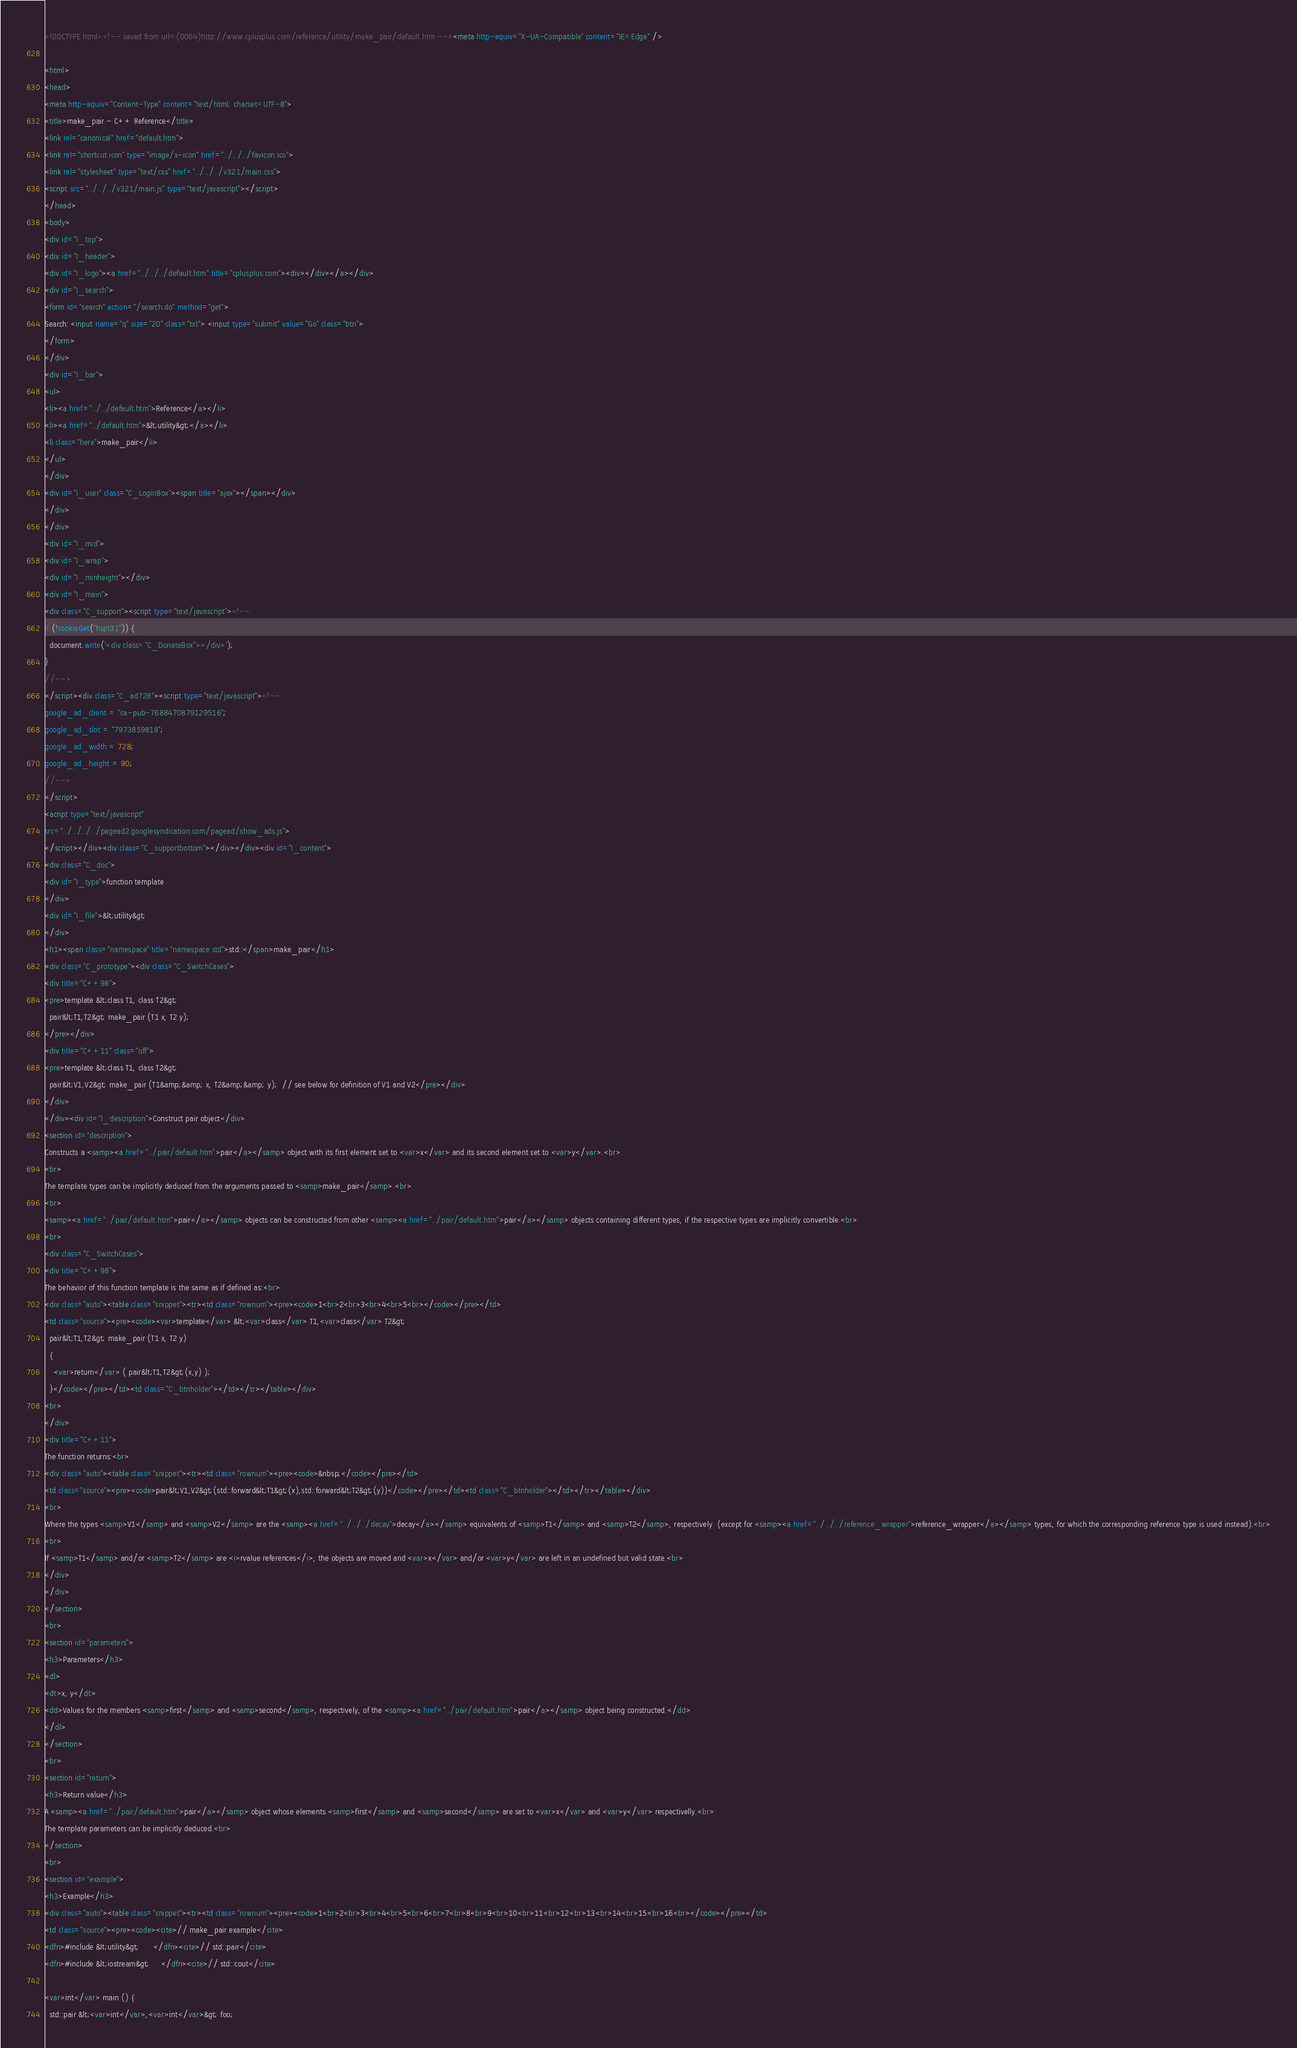<code> <loc_0><loc_0><loc_500><loc_500><_HTML_><!DOCTYPE html><!-- saved from url=(0064)http://www.cplusplus.com/reference/utility/make_pair/default.htm --><meta http-equiv="X-UA-Compatible" content="IE=Edge" />

<html>
<head>
<meta http-equiv="Content-Type" content="text/html; charset=UTF-8">
<title>make_pair - C++ Reference</title>
<link rel="canonical" href="default.htm">
<link rel="shortcut icon" type="image/x-icon" href="../../../favicon.ico">
<link rel="stylesheet" type="text/css" href="../../../v321/main.css">
<script src="../../../v321/main.js" type="text/javascript"></script>
</head>
<body>
<div id="I_top">
<div id="I_header">
<div id="I_logo"><a href="../../../default.htm" title="cplusplus.com"><div></div></a></div>
<div id="I_search">
<form id="search" action="/search.do" method="get">
Search: <input name="q" size="20" class="txt"> <input type="submit" value="Go" class="btn">
</form>
</div>
<div id="I_bar">
<ul>
<li><a href="../../default.htm">Reference</a></li>
<li><a href="../default.htm">&lt;utility&gt;</a></li>
<li class="here">make_pair</li>
</ul>
</div>
<div id="I_user" class="C_LoginBox"><span title="ajax"></span></div>
</div>
</div>
<div id="I_mid">
<div id="I_wrap">
<div id="I_minheight"></div>
<div id="I_main">
<div class="C_support"><script type="text/javascript"><!--
if (!cookieGet("hspt31")) {
  document.write('<div class="C_DonateBox"></div>');
}
//-->
</script><div class="C_ad728"><script type="text/javascript"><!--
google_ad_client = "ca-pub-7688470879129516";
google_ad_slot = "7973859818";
google_ad_width = 728;
google_ad_height = 90;
//-->
</script>
<acript type="text/javascript"
src="../../../../pagead2.googlesyndication.com/pagead/show_ads.js">
</script></div><div class="C_supportbottom"></div></div><div id="I_content">
<div class="C_doc">
<div id="I_type">function template</div>
<div id="I_file">&lt;utility&gt;</div>
<h1><span class="namespace" title="namespace std">std::</span>make_pair</h1>
<div class="C_prototype"><div class="C_SwitchCases">
<div title="C++98">
<pre>template &lt;class T1, class T2&gt;  pair&lt;T1,T2&gt; make_pair (T1 x, T2 y);</pre></div>
<div title="C++11" class="off">
<pre>template &lt;class T1, class T2&gt;  pair&lt;V1,V2&gt; make_pair (T1&amp;&amp; x, T2&amp;&amp; y);  // see below for definition of V1 and V2</pre></div>
</div>
</div><div id="I_description">Construct pair object</div>
<section id="description">
Constructs a <samp><a href="../pair/default.htm">pair</a></samp> object with its first element set to <var>x</var> and its second element set to <var>y</var>.<br>
<br>
The template types can be implicitly deduced from the arguments passed to <samp>make_pair</samp>.<br>
<br>
<samp><a href="../pair/default.htm">pair</a></samp> objects can be constructed from other <samp><a href="../pair/default.htm">pair</a></samp> objects containing different types, if the respective types are implicitly convertible.<br>
<br>
<div class="C_SwitchCases">
<div title="C++98">
The behavior of this function template is the same as if defined as:<br>
<div class="auto"><table class="snippet"><tr><td class="rownum"><pre><code>1<br>2<br>3<br>4<br>5<br></code></pre></td>
<td class="source"><pre><code><var>template</var> &lt;<var>class</var> T1,<var>class</var> T2&gt;
  pair&lt;T1,T2&gt; make_pair (T1 x, T2 y)
  {
    <var>return</var> ( pair&lt;T1,T2&gt;(x,y) );
  }</code></pre></td><td class="C_btnholder"></td></tr></table></div>
<br>
</div>
<div title="C++11">
The function returns:<br>
<div class="auto"><table class="snippet"><tr><td class="rownum"><pre><code>&nbsp;</code></pre></td>
<td class="source"><pre><code>pair&lt;V1,V2&gt;(std::forward&lt;T1&gt;(x),std::forward&lt;T2&gt;(y))</code></pre></td><td class="C_btnholder"></td></tr></table></div>
<br>
Where the types <samp>V1</samp> and <samp>V2</samp> are the <samp><a href="../../../decay">decay</a></samp> equivalents of <samp>T1</samp> and <samp>T2</samp>, respectively  (except for <samp><a href="../../../reference_wrapper">reference_wrapper</a></samp> types, for which the corresponding reference type is used instead).<br>
<br>
If <samp>T1</samp> and/or <samp>T2</samp> are <i>rvalue references</i>, the objects are moved and <var>x</var> and/or <var>y</var> are left in an undefined but valid state.<br>
</div>
</div>
</section>
<br>
<section id="parameters">
<h3>Parameters</h3>
<dl>
<dt>x, y</dt>
<dd>Values for the members <samp>first</samp> and <samp>second</samp>, respectively, of the <samp><a href="../pair/default.htm">pair</a></samp> object being constructed.</dd>
</dl>
</section>
<br>
<section id="return">
<h3>Return value</h3>
A <samp><a href="../pair/default.htm">pair</a></samp> object whose elements <samp>first</samp> and <samp>second</samp> are set to <var>x</var> and <var>y</var> respectivelly.<br>
The template parameters can be implicitly deduced.<br>
</section>
<br>
<section id="example">
<h3>Example</h3>
<div class="auto"><table class="snippet"><tr><td class="rownum"><pre><code>1<br>2<br>3<br>4<br>5<br>6<br>7<br>8<br>9<br>10<br>11<br>12<br>13<br>14<br>15<br>16<br></code></pre></td>
<td class="source"><pre><code><cite>// make_pair example</cite>
<dfn>#include &lt;utility&gt;      </dfn><cite>// std::pair</cite>
<dfn>#include &lt;iostream&gt;     </dfn><cite>// std::cout</cite>

<var>int</var> main () {
  std::pair &lt;<var>int</var>,<var>int</var>&gt; foo;</code> 